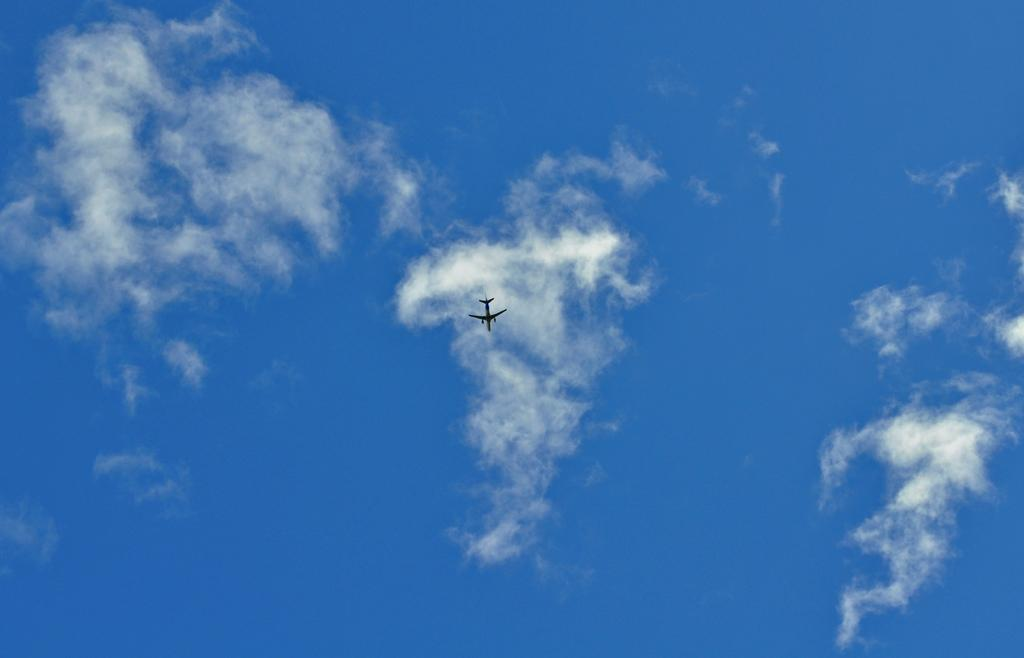What is the main subject of the image? The main subject of the image is an airplane. What is the airplane doing in the image? The airplane is flying in the sky. How would you describe the sky in the image? The sky appears cloudy. What type of meal is being served on the airplane in the image? There is no meal being served on the airplane in the image; it is focused on the airplane flying in the sky. How many goldfish can be seen swimming in the sky in the image? There are no goldfish present in the image; it only features an airplane flying in the sky. 